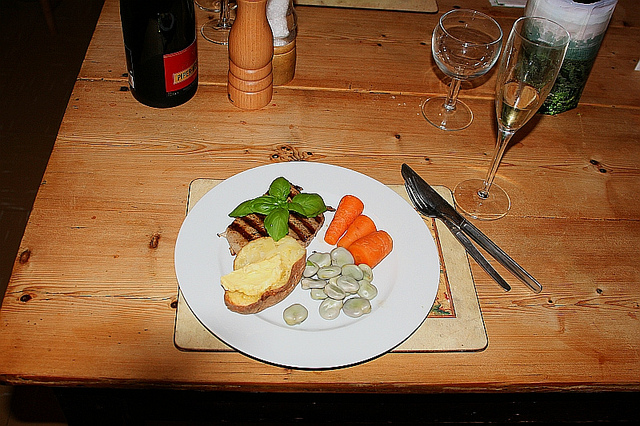<image>What utensils are on the plate? There are no utensils on the plate. However, it can be a fork and knife. What utensils are on the plate? There are no utensils on the plate. 